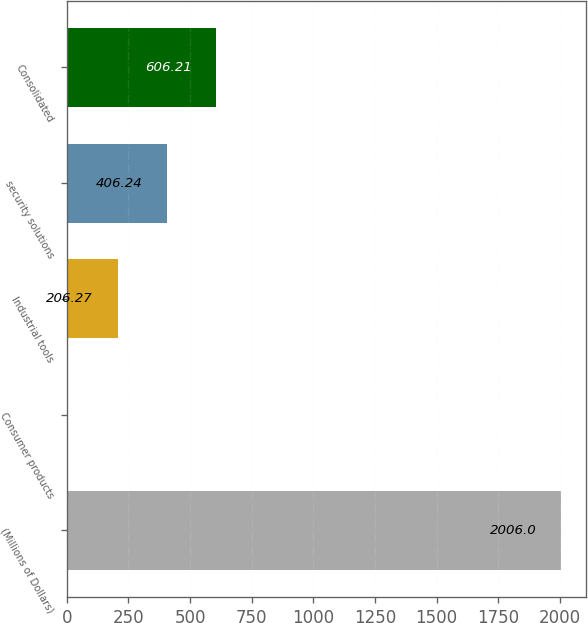Convert chart to OTSL. <chart><loc_0><loc_0><loc_500><loc_500><bar_chart><fcel>(Millions of Dollars)<fcel>Consumer products<fcel>Industrial tools<fcel>security solutions<fcel>Consolidated<nl><fcel>2006<fcel>6.3<fcel>206.27<fcel>406.24<fcel>606.21<nl></chart> 